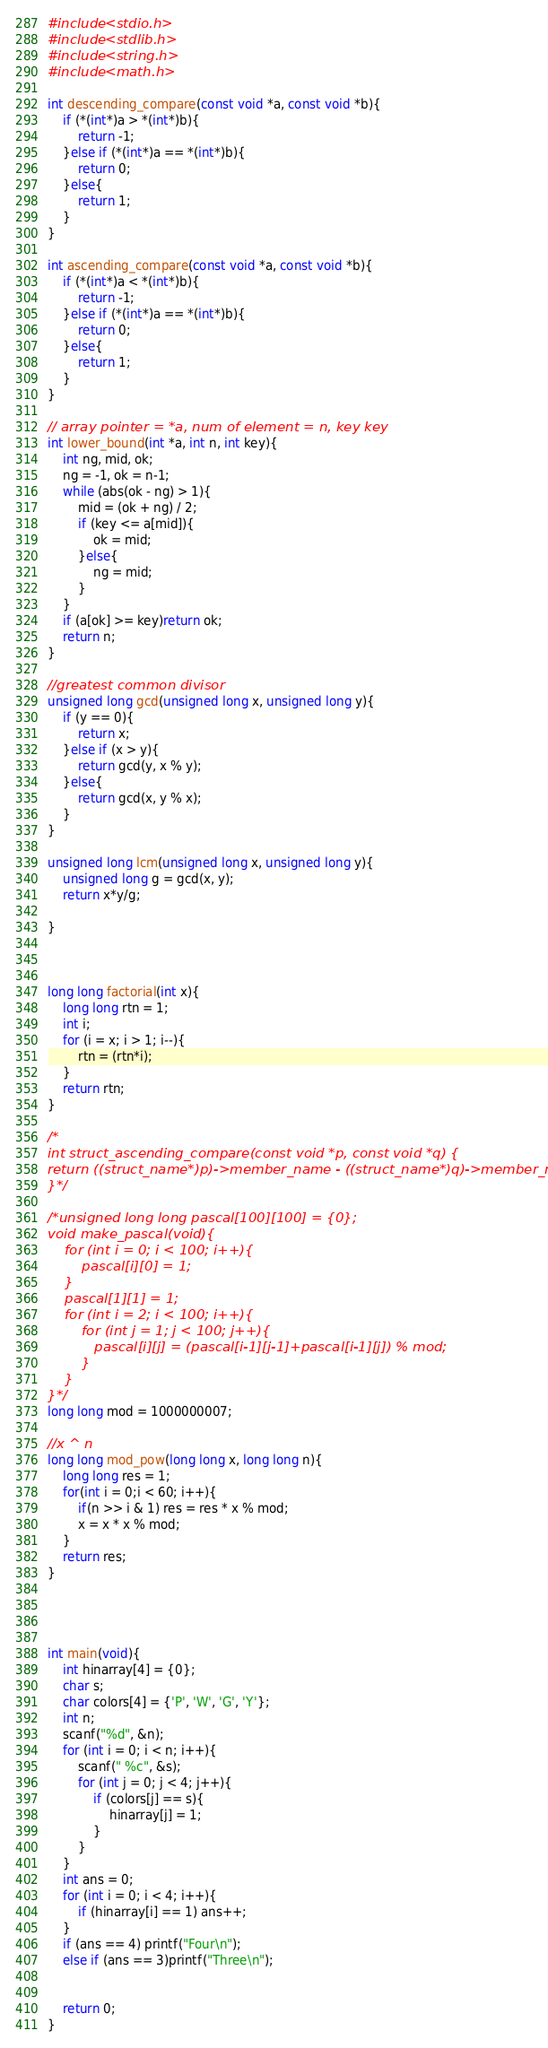<code> <loc_0><loc_0><loc_500><loc_500><_C_>#include <stdio.h>
#include <stdlib.h>
#include <string.h>
#include <math.h>

int descending_compare(const void *a, const void *b){
    if (*(int*)a > *(int*)b){
        return -1;
    }else if (*(int*)a == *(int*)b){
        return 0;
    }else{
        return 1;
    }
}

int ascending_compare(const void *a, const void *b){
    if (*(int*)a < *(int*)b){
        return -1;
    }else if (*(int*)a == *(int*)b){
        return 0;
    }else{
        return 1;
    }
}

// array pointer = *a, num of element = n, key key
int lower_bound(int *a, int n, int key){
    int ng, mid, ok;
    ng = -1, ok = n-1;
    while (abs(ok - ng) > 1){
        mid = (ok + ng) / 2;
        if (key <= a[mid]){
            ok = mid;
        }else{
            ng = mid;
        }
    }
    if (a[ok] >= key)return ok;
    return n;
}

//greatest common divisor
unsigned long gcd(unsigned long x, unsigned long y){
    if (y == 0){ 
        return x;
    }else if (x > y){
        return gcd(y, x % y);
    }else{
        return gcd(x, y % x);
    }
}

unsigned long lcm(unsigned long x, unsigned long y){
    unsigned long g = gcd(x, y);
    return x*y/g;

}



long long factorial(int x){
    long long rtn = 1;
    int i;
    for (i = x; i > 1; i--){
        rtn = (rtn*i);
    }
    return rtn;
}

/*
int struct_ascending_compare(const void *p, const void *q) {
return ((struct_name*)p)->member_name - ((struct_name*)q)->member_name;
}*/

/*unsigned long long pascal[100][100] = {0};
void make_pascal(void){
    for (int i = 0; i < 100; i++){
        pascal[i][0] = 1;
    }
    pascal[1][1] = 1;
    for (int i = 2; i < 100; i++){
        for (int j = 1; j < 100; j++){
           pascal[i][j] = (pascal[i-1][j-1]+pascal[i-1][j]) % mod;
        }
    }
}*/
long long mod = 1000000007;

//x ^ n
long long mod_pow(long long x, long long n){
    long long res = 1;
    for(int i = 0;i < 60; i++){
        if(n >> i & 1) res = res * x % mod;
        x = x * x % mod;
    }
    return res;
}




int main(void){
    int hinarray[4] = {0};
    char s;
    char colors[4] = {'P', 'W', 'G', 'Y'};
    int n;
    scanf("%d", &n);
    for (int i = 0; i < n; i++){
        scanf(" %c", &s);
        for (int j = 0; j < 4; j++){
            if (colors[j] == s){
                hinarray[j] = 1;
            }
        }
    }
    int ans = 0;
    for (int i = 0; i < 4; i++){
        if (hinarray[i] == 1) ans++;
    }
    if (ans == 4) printf("Four\n");
    else if (ans == 3)printf("Three\n");


    return 0;
}
</code> 